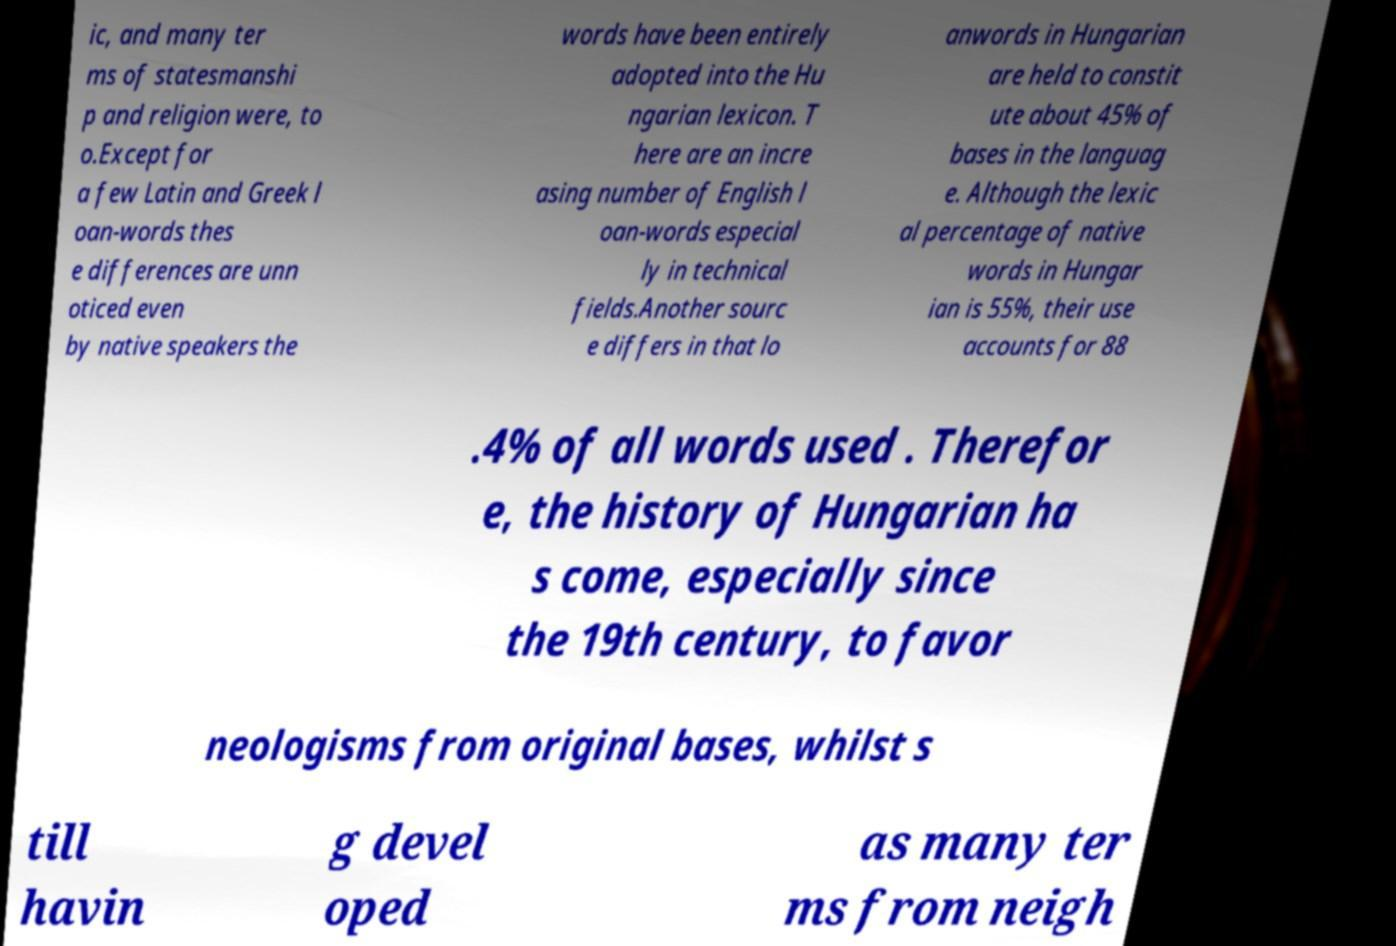Can you read and provide the text displayed in the image?This photo seems to have some interesting text. Can you extract and type it out for me? ic, and many ter ms of statesmanshi p and religion were, to o.Except for a few Latin and Greek l oan-words thes e differences are unn oticed even by native speakers the words have been entirely adopted into the Hu ngarian lexicon. T here are an incre asing number of English l oan-words especial ly in technical fields.Another sourc e differs in that lo anwords in Hungarian are held to constit ute about 45% of bases in the languag e. Although the lexic al percentage of native words in Hungar ian is 55%, their use accounts for 88 .4% of all words used . Therefor e, the history of Hungarian ha s come, especially since the 19th century, to favor neologisms from original bases, whilst s till havin g devel oped as many ter ms from neigh 